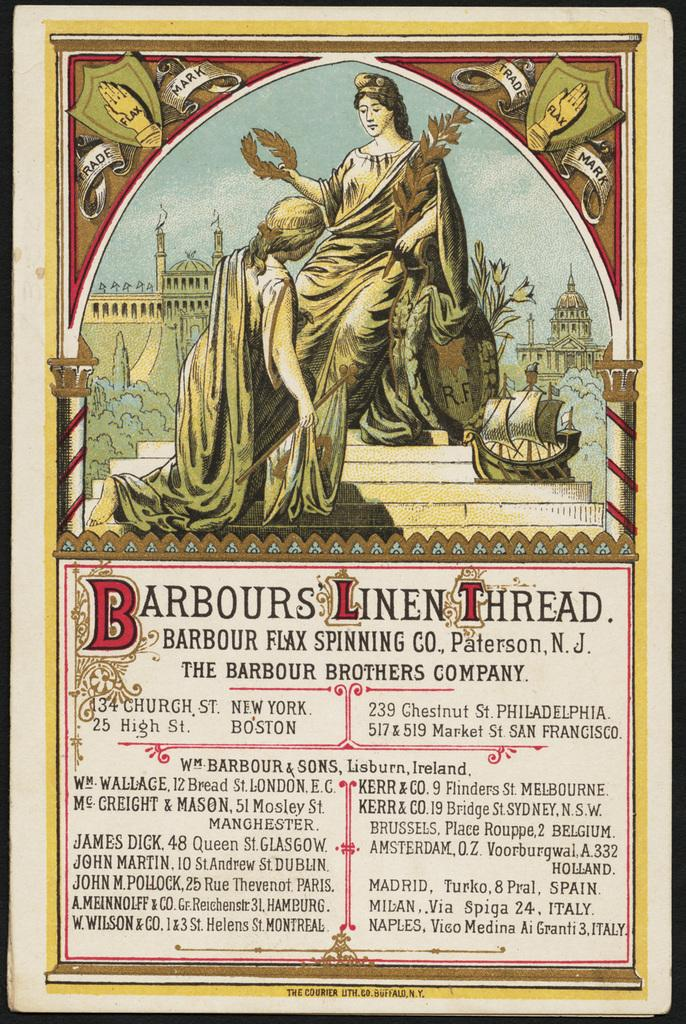Provide a one-sentence caption for the provided image. An advertisement that is for Barbours Linen Thread. 